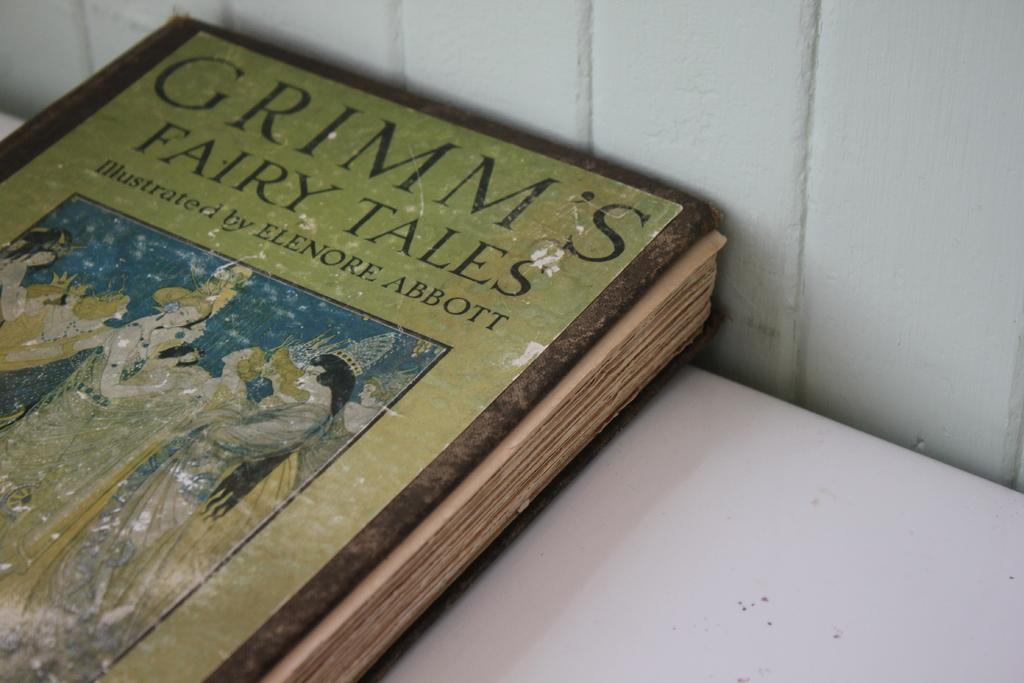<image>
Share a concise interpretation of the image provided. A Grimm's Fairy Tales book sitting on a white table. 